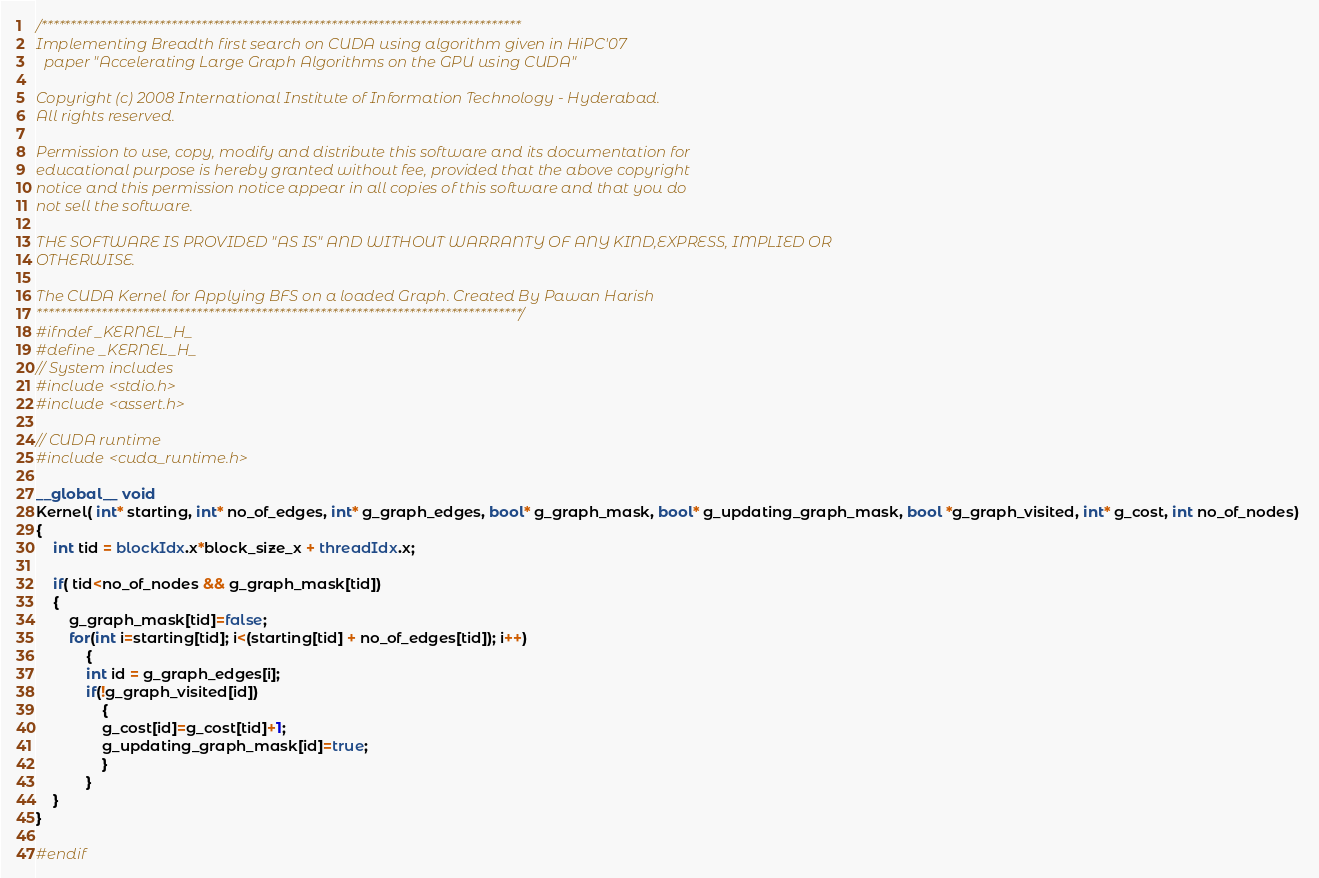Convert code to text. <code><loc_0><loc_0><loc_500><loc_500><_Cuda_>/*********************************************************************************
Implementing Breadth first search on CUDA using algorithm given in HiPC'07
  paper "Accelerating Large Graph Algorithms on the GPU using CUDA"

Copyright (c) 2008 International Institute of Information Technology - Hyderabad. 
All rights reserved.
  
Permission to use, copy, modify and distribute this software and its documentation for 
educational purpose is hereby granted without fee, provided that the above copyright 
notice and this permission notice appear in all copies of this software and that you do 
not sell the software.
  
THE SOFTWARE IS PROVIDED "AS IS" AND WITHOUT WARRANTY OF ANY KIND,EXPRESS, IMPLIED OR 
OTHERWISE.

The CUDA Kernel for Applying BFS on a loaded Graph. Created By Pawan Harish
**********************************************************************************/
#ifndef _KERNEL_H_
#define _KERNEL_H_
// System includes
#include <stdio.h>
#include <assert.h>

// CUDA runtime
#include <cuda_runtime.h>

__global__ void
Kernel( int* starting, int* no_of_edges, int* g_graph_edges, bool* g_graph_mask, bool* g_updating_graph_mask, bool *g_graph_visited, int* g_cost, int no_of_nodes) 
{
	int tid = blockIdx.x*block_size_x + threadIdx.x;
	
	if( tid<no_of_nodes && g_graph_mask[tid])
	{	
		g_graph_mask[tid]=false;
		for(int i=starting[tid]; i<(starting[tid] + no_of_edges[tid]); i++)
			{
			int id = g_graph_edges[i];
			if(!g_graph_visited[id])
				{
				g_cost[id]=g_cost[tid]+1;
				g_updating_graph_mask[id]=true;
				}
			}
	}
}

#endif 
</code> 